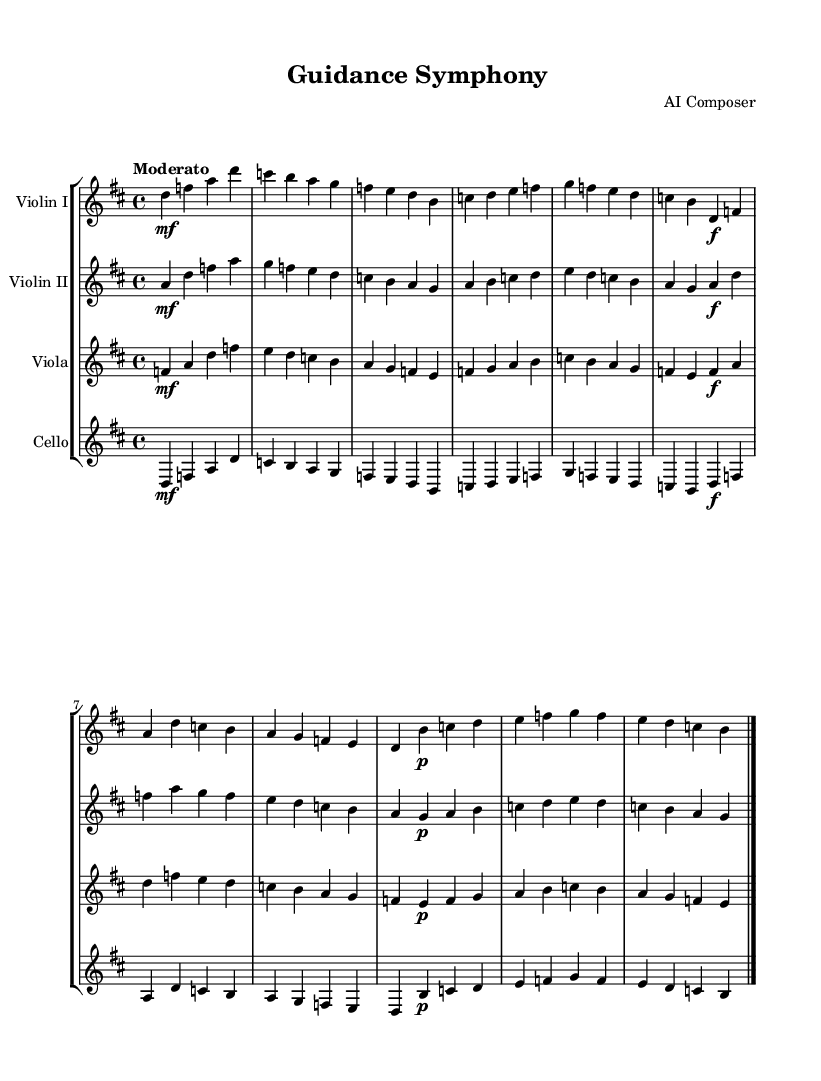What is the key signature of this music? The key signature is D major, which has two sharps, F# and C#. You can identify this from the presence of the key signature marked at the beginning of the staff.
Answer: D major What is the time signature of this piece? The time signature is 4/4, meaning each measure has four beats and the quarter note gets one beat. This is indicated at the beginning of the score.
Answer: 4/4 What is the tempo marking for this symphony? The tempo marking is "Moderato". This is indicated above the staff to provide guidance on the speed of the performance.
Answer: Moderato How many instruments are in this symphony? There are four instruments: Violin I, Violin II, Viola, and Cello. Each instrument is represented by its own staff in the score, making it easy to count them.
Answer: Four Which instrument has the lowest pitch? The instrument with the lowest pitch is the Cello. In the score, the cello part is generally notated lower than the other instruments, reflecting its range.
Answer: Cello What dynamic marking appears in the first theme for Violin I? The dynamic marking in the first theme for Violin I is "mf," indicating a moderately loud volume. This can be found at the beginning of Violin I's staff.
Answer: mf In which section of the score would you typically find thematic material? Thematic material is typically found at the beginning of the score, where the main themes or ideas are introduced. This section often sets the tone for the piece.
Answer: Beginning 